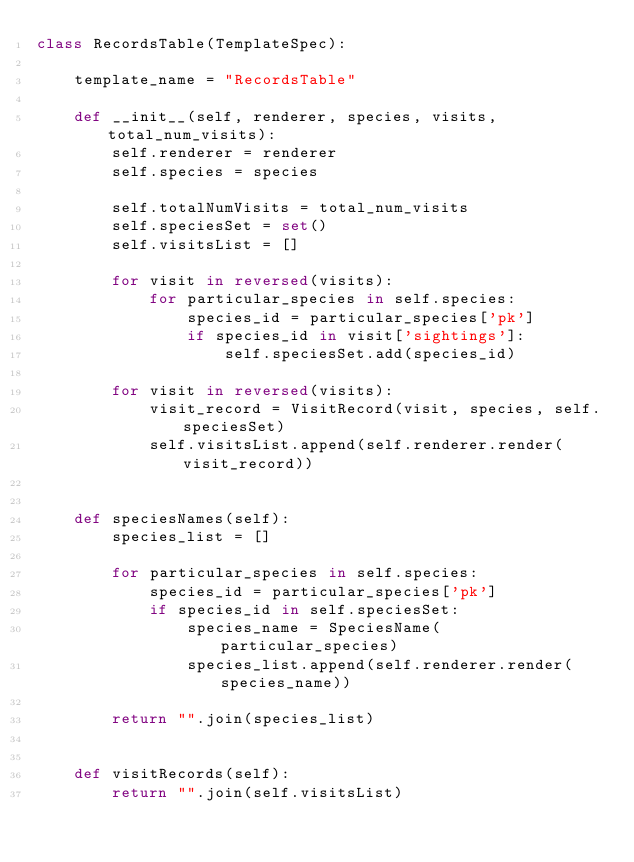Convert code to text. <code><loc_0><loc_0><loc_500><loc_500><_Python_>class RecordsTable(TemplateSpec):

	template_name = "RecordsTable"

	def __init__(self, renderer, species, visits, total_num_visits):
		self.renderer = renderer
		self.species = species

		self.totalNumVisits = total_num_visits
		self.speciesSet = set()
		self.visitsList = []

		for visit in reversed(visits):
			for particular_species in self.species:
				species_id = particular_species['pk']
				if species_id in visit['sightings']:
					self.speciesSet.add(species_id)

		for visit in reversed(visits):
			visit_record = VisitRecord(visit, species, self.speciesSet)
			self.visitsList.append(self.renderer.render(visit_record))


	def speciesNames(self):
		species_list = []

		for particular_species in self.species:
			species_id = particular_species['pk']
			if species_id in self.speciesSet:
				species_name = SpeciesName(particular_species)
				species_list.append(self.renderer.render(species_name))

		return "".join(species_list)


	def visitRecords(self):
		return "".join(self.visitsList)
</code> 